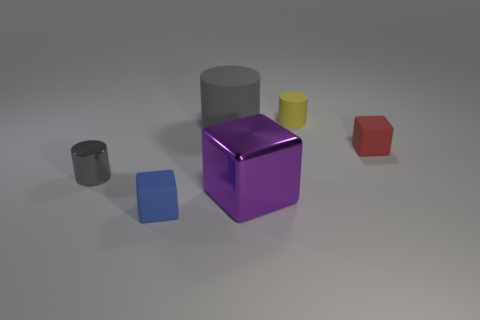Do the small matte cylinder and the shiny thing that is on the left side of the gray rubber cylinder have the same color?
Offer a terse response. No. Are there fewer large shiny blocks that are on the right side of the tiny yellow cylinder than tiny matte things?
Your answer should be compact. Yes. What number of small red matte things are there?
Offer a very short reply. 1. There is a large thing that is on the right side of the gray object behind the small red thing; what is its shape?
Your response must be concise. Cube. There is a yellow rubber thing; how many small red matte blocks are behind it?
Ensure brevity in your answer.  0. Do the big purple thing and the gray object that is behind the gray metallic object have the same material?
Ensure brevity in your answer.  No. Is there a blue rubber thing of the same size as the gray matte cylinder?
Provide a succinct answer. No. Are there the same number of small cubes that are on the right side of the big purple block and tiny yellow balls?
Your answer should be very brief. No. What size is the gray rubber thing?
Give a very brief answer. Large. There is a big object on the left side of the purple metallic object; what number of metallic things are behind it?
Your answer should be compact. 0. 